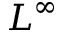Convert formula to latex. <formula><loc_0><loc_0><loc_500><loc_500>L ^ { \infty }</formula> 